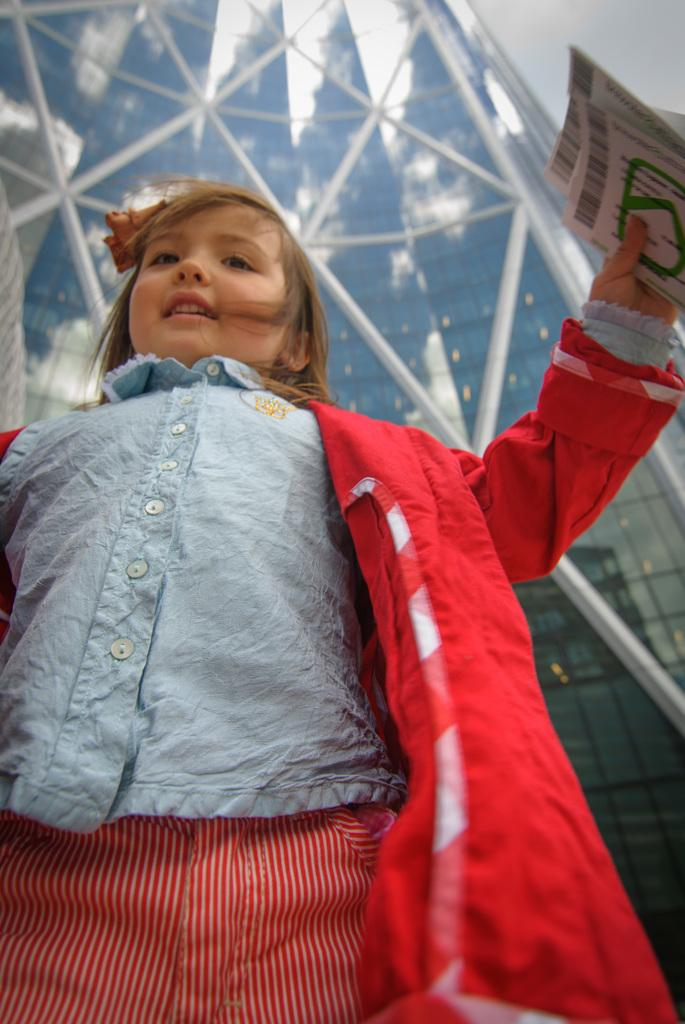Who is the main subject in the image? There is a girl in the image. What is the girl doing in the image? The girl is standing in the image. What is the girl wearing in the image? The girl is wearing a blue shirt and a red coat in the image. What is the girl holding in her hand in the image? The girl is holding papers in her hand in the image. What can be seen in the background of the image? There is a building in the background of the image. What type of cable is the girl using to hold the papers in the image? There is no cable present in the image; the girl is holding the papers with her hand. 